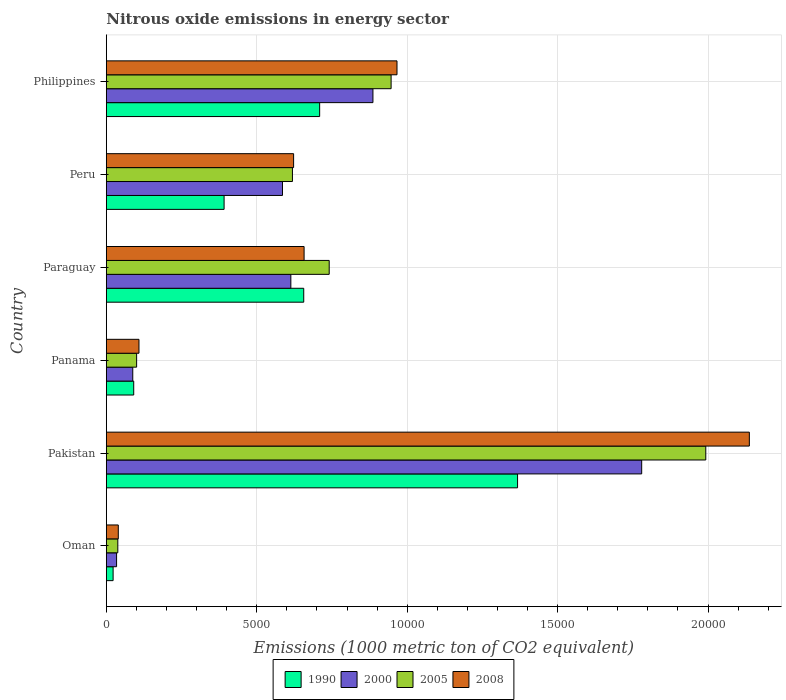How many groups of bars are there?
Offer a terse response. 6. What is the label of the 2nd group of bars from the top?
Ensure brevity in your answer.  Peru. What is the amount of nitrous oxide emitted in 1990 in Philippines?
Provide a succinct answer. 7090.2. Across all countries, what is the maximum amount of nitrous oxide emitted in 2005?
Provide a succinct answer. 1.99e+04. Across all countries, what is the minimum amount of nitrous oxide emitted in 2008?
Ensure brevity in your answer.  397.4. In which country was the amount of nitrous oxide emitted in 1990 minimum?
Your answer should be very brief. Oman. What is the total amount of nitrous oxide emitted in 2005 in the graph?
Ensure brevity in your answer.  4.44e+04. What is the difference between the amount of nitrous oxide emitted in 1990 in Oman and that in Panama?
Offer a terse response. -685.4. What is the difference between the amount of nitrous oxide emitted in 1990 in Panama and the amount of nitrous oxide emitted in 2008 in Pakistan?
Provide a short and direct response. -2.05e+04. What is the average amount of nitrous oxide emitted in 1990 per country?
Keep it short and to the point. 5394.85. What is the difference between the amount of nitrous oxide emitted in 2005 and amount of nitrous oxide emitted in 2008 in Paraguay?
Your answer should be compact. 834.7. What is the ratio of the amount of nitrous oxide emitted in 2005 in Pakistan to that in Paraguay?
Your response must be concise. 2.69. What is the difference between the highest and the second highest amount of nitrous oxide emitted in 2005?
Offer a terse response. 1.05e+04. What is the difference between the highest and the lowest amount of nitrous oxide emitted in 1990?
Give a very brief answer. 1.34e+04. In how many countries, is the amount of nitrous oxide emitted in 2008 greater than the average amount of nitrous oxide emitted in 2008 taken over all countries?
Offer a terse response. 2. Is it the case that in every country, the sum of the amount of nitrous oxide emitted in 2000 and amount of nitrous oxide emitted in 2005 is greater than the sum of amount of nitrous oxide emitted in 1990 and amount of nitrous oxide emitted in 2008?
Provide a short and direct response. No. What does the 4th bar from the top in Philippines represents?
Keep it short and to the point. 1990. Is it the case that in every country, the sum of the amount of nitrous oxide emitted in 2005 and amount of nitrous oxide emitted in 1990 is greater than the amount of nitrous oxide emitted in 2008?
Your answer should be compact. Yes. Are all the bars in the graph horizontal?
Offer a terse response. Yes. How many countries are there in the graph?
Your answer should be compact. 6. Are the values on the major ticks of X-axis written in scientific E-notation?
Your answer should be compact. No. Does the graph contain grids?
Your response must be concise. Yes. How many legend labels are there?
Ensure brevity in your answer.  4. What is the title of the graph?
Provide a succinct answer. Nitrous oxide emissions in energy sector. What is the label or title of the X-axis?
Your answer should be very brief. Emissions (1000 metric ton of CO2 equivalent). What is the Emissions (1000 metric ton of CO2 equivalent) of 1990 in Oman?
Ensure brevity in your answer.  225. What is the Emissions (1000 metric ton of CO2 equivalent) in 2000 in Oman?
Ensure brevity in your answer.  340.4. What is the Emissions (1000 metric ton of CO2 equivalent) in 2005 in Oman?
Provide a short and direct response. 381.4. What is the Emissions (1000 metric ton of CO2 equivalent) of 2008 in Oman?
Your answer should be compact. 397.4. What is the Emissions (1000 metric ton of CO2 equivalent) in 1990 in Pakistan?
Keep it short and to the point. 1.37e+04. What is the Emissions (1000 metric ton of CO2 equivalent) in 2000 in Pakistan?
Provide a short and direct response. 1.78e+04. What is the Emissions (1000 metric ton of CO2 equivalent) in 2005 in Pakistan?
Give a very brief answer. 1.99e+04. What is the Emissions (1000 metric ton of CO2 equivalent) in 2008 in Pakistan?
Offer a very short reply. 2.14e+04. What is the Emissions (1000 metric ton of CO2 equivalent) of 1990 in Panama?
Your answer should be compact. 910.4. What is the Emissions (1000 metric ton of CO2 equivalent) of 2000 in Panama?
Keep it short and to the point. 878.4. What is the Emissions (1000 metric ton of CO2 equivalent) in 2005 in Panama?
Provide a succinct answer. 1006.8. What is the Emissions (1000 metric ton of CO2 equivalent) of 2008 in Panama?
Offer a terse response. 1084.9. What is the Emissions (1000 metric ton of CO2 equivalent) in 1990 in Paraguay?
Keep it short and to the point. 6561.2. What is the Emissions (1000 metric ton of CO2 equivalent) in 2000 in Paraguay?
Make the answer very short. 6132.8. What is the Emissions (1000 metric ton of CO2 equivalent) of 2005 in Paraguay?
Your answer should be very brief. 7407.7. What is the Emissions (1000 metric ton of CO2 equivalent) in 2008 in Paraguay?
Ensure brevity in your answer.  6573. What is the Emissions (1000 metric ton of CO2 equivalent) in 1990 in Peru?
Provide a succinct answer. 3914.1. What is the Emissions (1000 metric ton of CO2 equivalent) in 2000 in Peru?
Offer a terse response. 5854.9. What is the Emissions (1000 metric ton of CO2 equivalent) of 2005 in Peru?
Your response must be concise. 6185.8. What is the Emissions (1000 metric ton of CO2 equivalent) in 2008 in Peru?
Provide a succinct answer. 6224.5. What is the Emissions (1000 metric ton of CO2 equivalent) of 1990 in Philippines?
Offer a very short reply. 7090.2. What is the Emissions (1000 metric ton of CO2 equivalent) of 2000 in Philippines?
Your response must be concise. 8861.1. What is the Emissions (1000 metric ton of CO2 equivalent) in 2005 in Philippines?
Provide a succinct answer. 9465.1. What is the Emissions (1000 metric ton of CO2 equivalent) of 2008 in Philippines?
Your answer should be compact. 9660.8. Across all countries, what is the maximum Emissions (1000 metric ton of CO2 equivalent) in 1990?
Provide a short and direct response. 1.37e+04. Across all countries, what is the maximum Emissions (1000 metric ton of CO2 equivalent) in 2000?
Make the answer very short. 1.78e+04. Across all countries, what is the maximum Emissions (1000 metric ton of CO2 equivalent) of 2005?
Your response must be concise. 1.99e+04. Across all countries, what is the maximum Emissions (1000 metric ton of CO2 equivalent) in 2008?
Make the answer very short. 2.14e+04. Across all countries, what is the minimum Emissions (1000 metric ton of CO2 equivalent) of 1990?
Ensure brevity in your answer.  225. Across all countries, what is the minimum Emissions (1000 metric ton of CO2 equivalent) of 2000?
Offer a terse response. 340.4. Across all countries, what is the minimum Emissions (1000 metric ton of CO2 equivalent) in 2005?
Offer a terse response. 381.4. Across all countries, what is the minimum Emissions (1000 metric ton of CO2 equivalent) of 2008?
Offer a very short reply. 397.4. What is the total Emissions (1000 metric ton of CO2 equivalent) in 1990 in the graph?
Provide a short and direct response. 3.24e+04. What is the total Emissions (1000 metric ton of CO2 equivalent) of 2000 in the graph?
Your response must be concise. 3.99e+04. What is the total Emissions (1000 metric ton of CO2 equivalent) in 2005 in the graph?
Provide a short and direct response. 4.44e+04. What is the total Emissions (1000 metric ton of CO2 equivalent) in 2008 in the graph?
Your answer should be compact. 4.53e+04. What is the difference between the Emissions (1000 metric ton of CO2 equivalent) of 1990 in Oman and that in Pakistan?
Your response must be concise. -1.34e+04. What is the difference between the Emissions (1000 metric ton of CO2 equivalent) of 2000 in Oman and that in Pakistan?
Keep it short and to the point. -1.75e+04. What is the difference between the Emissions (1000 metric ton of CO2 equivalent) of 2005 in Oman and that in Pakistan?
Give a very brief answer. -1.95e+04. What is the difference between the Emissions (1000 metric ton of CO2 equivalent) in 2008 in Oman and that in Pakistan?
Keep it short and to the point. -2.10e+04. What is the difference between the Emissions (1000 metric ton of CO2 equivalent) of 1990 in Oman and that in Panama?
Give a very brief answer. -685.4. What is the difference between the Emissions (1000 metric ton of CO2 equivalent) of 2000 in Oman and that in Panama?
Your answer should be very brief. -538. What is the difference between the Emissions (1000 metric ton of CO2 equivalent) of 2005 in Oman and that in Panama?
Your answer should be compact. -625.4. What is the difference between the Emissions (1000 metric ton of CO2 equivalent) of 2008 in Oman and that in Panama?
Keep it short and to the point. -687.5. What is the difference between the Emissions (1000 metric ton of CO2 equivalent) in 1990 in Oman and that in Paraguay?
Your answer should be very brief. -6336.2. What is the difference between the Emissions (1000 metric ton of CO2 equivalent) of 2000 in Oman and that in Paraguay?
Provide a short and direct response. -5792.4. What is the difference between the Emissions (1000 metric ton of CO2 equivalent) of 2005 in Oman and that in Paraguay?
Make the answer very short. -7026.3. What is the difference between the Emissions (1000 metric ton of CO2 equivalent) of 2008 in Oman and that in Paraguay?
Ensure brevity in your answer.  -6175.6. What is the difference between the Emissions (1000 metric ton of CO2 equivalent) of 1990 in Oman and that in Peru?
Your answer should be compact. -3689.1. What is the difference between the Emissions (1000 metric ton of CO2 equivalent) in 2000 in Oman and that in Peru?
Offer a very short reply. -5514.5. What is the difference between the Emissions (1000 metric ton of CO2 equivalent) of 2005 in Oman and that in Peru?
Your answer should be very brief. -5804.4. What is the difference between the Emissions (1000 metric ton of CO2 equivalent) in 2008 in Oman and that in Peru?
Provide a short and direct response. -5827.1. What is the difference between the Emissions (1000 metric ton of CO2 equivalent) of 1990 in Oman and that in Philippines?
Keep it short and to the point. -6865.2. What is the difference between the Emissions (1000 metric ton of CO2 equivalent) in 2000 in Oman and that in Philippines?
Offer a very short reply. -8520.7. What is the difference between the Emissions (1000 metric ton of CO2 equivalent) of 2005 in Oman and that in Philippines?
Make the answer very short. -9083.7. What is the difference between the Emissions (1000 metric ton of CO2 equivalent) in 2008 in Oman and that in Philippines?
Your answer should be very brief. -9263.4. What is the difference between the Emissions (1000 metric ton of CO2 equivalent) in 1990 in Pakistan and that in Panama?
Provide a short and direct response. 1.28e+04. What is the difference between the Emissions (1000 metric ton of CO2 equivalent) in 2000 in Pakistan and that in Panama?
Your answer should be very brief. 1.69e+04. What is the difference between the Emissions (1000 metric ton of CO2 equivalent) in 2005 in Pakistan and that in Panama?
Make the answer very short. 1.89e+04. What is the difference between the Emissions (1000 metric ton of CO2 equivalent) of 2008 in Pakistan and that in Panama?
Offer a very short reply. 2.03e+04. What is the difference between the Emissions (1000 metric ton of CO2 equivalent) of 1990 in Pakistan and that in Paraguay?
Provide a succinct answer. 7107. What is the difference between the Emissions (1000 metric ton of CO2 equivalent) of 2000 in Pakistan and that in Paraguay?
Make the answer very short. 1.17e+04. What is the difference between the Emissions (1000 metric ton of CO2 equivalent) of 2005 in Pakistan and that in Paraguay?
Provide a short and direct response. 1.25e+04. What is the difference between the Emissions (1000 metric ton of CO2 equivalent) of 2008 in Pakistan and that in Paraguay?
Make the answer very short. 1.48e+04. What is the difference between the Emissions (1000 metric ton of CO2 equivalent) in 1990 in Pakistan and that in Peru?
Offer a very short reply. 9754.1. What is the difference between the Emissions (1000 metric ton of CO2 equivalent) in 2000 in Pakistan and that in Peru?
Ensure brevity in your answer.  1.19e+04. What is the difference between the Emissions (1000 metric ton of CO2 equivalent) in 2005 in Pakistan and that in Peru?
Make the answer very short. 1.37e+04. What is the difference between the Emissions (1000 metric ton of CO2 equivalent) of 2008 in Pakistan and that in Peru?
Ensure brevity in your answer.  1.51e+04. What is the difference between the Emissions (1000 metric ton of CO2 equivalent) of 1990 in Pakistan and that in Philippines?
Offer a very short reply. 6578. What is the difference between the Emissions (1000 metric ton of CO2 equivalent) in 2000 in Pakistan and that in Philippines?
Provide a short and direct response. 8932.4. What is the difference between the Emissions (1000 metric ton of CO2 equivalent) in 2005 in Pakistan and that in Philippines?
Your response must be concise. 1.05e+04. What is the difference between the Emissions (1000 metric ton of CO2 equivalent) of 2008 in Pakistan and that in Philippines?
Ensure brevity in your answer.  1.17e+04. What is the difference between the Emissions (1000 metric ton of CO2 equivalent) of 1990 in Panama and that in Paraguay?
Offer a terse response. -5650.8. What is the difference between the Emissions (1000 metric ton of CO2 equivalent) of 2000 in Panama and that in Paraguay?
Ensure brevity in your answer.  -5254.4. What is the difference between the Emissions (1000 metric ton of CO2 equivalent) of 2005 in Panama and that in Paraguay?
Keep it short and to the point. -6400.9. What is the difference between the Emissions (1000 metric ton of CO2 equivalent) of 2008 in Panama and that in Paraguay?
Ensure brevity in your answer.  -5488.1. What is the difference between the Emissions (1000 metric ton of CO2 equivalent) of 1990 in Panama and that in Peru?
Provide a succinct answer. -3003.7. What is the difference between the Emissions (1000 metric ton of CO2 equivalent) of 2000 in Panama and that in Peru?
Ensure brevity in your answer.  -4976.5. What is the difference between the Emissions (1000 metric ton of CO2 equivalent) in 2005 in Panama and that in Peru?
Make the answer very short. -5179. What is the difference between the Emissions (1000 metric ton of CO2 equivalent) of 2008 in Panama and that in Peru?
Your answer should be compact. -5139.6. What is the difference between the Emissions (1000 metric ton of CO2 equivalent) in 1990 in Panama and that in Philippines?
Keep it short and to the point. -6179.8. What is the difference between the Emissions (1000 metric ton of CO2 equivalent) of 2000 in Panama and that in Philippines?
Provide a short and direct response. -7982.7. What is the difference between the Emissions (1000 metric ton of CO2 equivalent) in 2005 in Panama and that in Philippines?
Offer a very short reply. -8458.3. What is the difference between the Emissions (1000 metric ton of CO2 equivalent) in 2008 in Panama and that in Philippines?
Give a very brief answer. -8575.9. What is the difference between the Emissions (1000 metric ton of CO2 equivalent) of 1990 in Paraguay and that in Peru?
Your answer should be compact. 2647.1. What is the difference between the Emissions (1000 metric ton of CO2 equivalent) in 2000 in Paraguay and that in Peru?
Ensure brevity in your answer.  277.9. What is the difference between the Emissions (1000 metric ton of CO2 equivalent) in 2005 in Paraguay and that in Peru?
Your answer should be compact. 1221.9. What is the difference between the Emissions (1000 metric ton of CO2 equivalent) of 2008 in Paraguay and that in Peru?
Your response must be concise. 348.5. What is the difference between the Emissions (1000 metric ton of CO2 equivalent) of 1990 in Paraguay and that in Philippines?
Your answer should be compact. -529. What is the difference between the Emissions (1000 metric ton of CO2 equivalent) of 2000 in Paraguay and that in Philippines?
Ensure brevity in your answer.  -2728.3. What is the difference between the Emissions (1000 metric ton of CO2 equivalent) of 2005 in Paraguay and that in Philippines?
Your answer should be compact. -2057.4. What is the difference between the Emissions (1000 metric ton of CO2 equivalent) in 2008 in Paraguay and that in Philippines?
Provide a short and direct response. -3087.8. What is the difference between the Emissions (1000 metric ton of CO2 equivalent) of 1990 in Peru and that in Philippines?
Provide a short and direct response. -3176.1. What is the difference between the Emissions (1000 metric ton of CO2 equivalent) of 2000 in Peru and that in Philippines?
Ensure brevity in your answer.  -3006.2. What is the difference between the Emissions (1000 metric ton of CO2 equivalent) in 2005 in Peru and that in Philippines?
Provide a succinct answer. -3279.3. What is the difference between the Emissions (1000 metric ton of CO2 equivalent) of 2008 in Peru and that in Philippines?
Ensure brevity in your answer.  -3436.3. What is the difference between the Emissions (1000 metric ton of CO2 equivalent) of 1990 in Oman and the Emissions (1000 metric ton of CO2 equivalent) of 2000 in Pakistan?
Give a very brief answer. -1.76e+04. What is the difference between the Emissions (1000 metric ton of CO2 equivalent) in 1990 in Oman and the Emissions (1000 metric ton of CO2 equivalent) in 2005 in Pakistan?
Provide a succinct answer. -1.97e+04. What is the difference between the Emissions (1000 metric ton of CO2 equivalent) in 1990 in Oman and the Emissions (1000 metric ton of CO2 equivalent) in 2008 in Pakistan?
Give a very brief answer. -2.11e+04. What is the difference between the Emissions (1000 metric ton of CO2 equivalent) of 2000 in Oman and the Emissions (1000 metric ton of CO2 equivalent) of 2005 in Pakistan?
Your answer should be very brief. -1.96e+04. What is the difference between the Emissions (1000 metric ton of CO2 equivalent) in 2000 in Oman and the Emissions (1000 metric ton of CO2 equivalent) in 2008 in Pakistan?
Your answer should be compact. -2.10e+04. What is the difference between the Emissions (1000 metric ton of CO2 equivalent) of 2005 in Oman and the Emissions (1000 metric ton of CO2 equivalent) of 2008 in Pakistan?
Offer a very short reply. -2.10e+04. What is the difference between the Emissions (1000 metric ton of CO2 equivalent) in 1990 in Oman and the Emissions (1000 metric ton of CO2 equivalent) in 2000 in Panama?
Give a very brief answer. -653.4. What is the difference between the Emissions (1000 metric ton of CO2 equivalent) of 1990 in Oman and the Emissions (1000 metric ton of CO2 equivalent) of 2005 in Panama?
Your answer should be very brief. -781.8. What is the difference between the Emissions (1000 metric ton of CO2 equivalent) in 1990 in Oman and the Emissions (1000 metric ton of CO2 equivalent) in 2008 in Panama?
Your response must be concise. -859.9. What is the difference between the Emissions (1000 metric ton of CO2 equivalent) of 2000 in Oman and the Emissions (1000 metric ton of CO2 equivalent) of 2005 in Panama?
Ensure brevity in your answer.  -666.4. What is the difference between the Emissions (1000 metric ton of CO2 equivalent) of 2000 in Oman and the Emissions (1000 metric ton of CO2 equivalent) of 2008 in Panama?
Ensure brevity in your answer.  -744.5. What is the difference between the Emissions (1000 metric ton of CO2 equivalent) in 2005 in Oman and the Emissions (1000 metric ton of CO2 equivalent) in 2008 in Panama?
Your answer should be compact. -703.5. What is the difference between the Emissions (1000 metric ton of CO2 equivalent) of 1990 in Oman and the Emissions (1000 metric ton of CO2 equivalent) of 2000 in Paraguay?
Keep it short and to the point. -5907.8. What is the difference between the Emissions (1000 metric ton of CO2 equivalent) of 1990 in Oman and the Emissions (1000 metric ton of CO2 equivalent) of 2005 in Paraguay?
Offer a very short reply. -7182.7. What is the difference between the Emissions (1000 metric ton of CO2 equivalent) of 1990 in Oman and the Emissions (1000 metric ton of CO2 equivalent) of 2008 in Paraguay?
Your answer should be compact. -6348. What is the difference between the Emissions (1000 metric ton of CO2 equivalent) of 2000 in Oman and the Emissions (1000 metric ton of CO2 equivalent) of 2005 in Paraguay?
Your answer should be very brief. -7067.3. What is the difference between the Emissions (1000 metric ton of CO2 equivalent) of 2000 in Oman and the Emissions (1000 metric ton of CO2 equivalent) of 2008 in Paraguay?
Give a very brief answer. -6232.6. What is the difference between the Emissions (1000 metric ton of CO2 equivalent) in 2005 in Oman and the Emissions (1000 metric ton of CO2 equivalent) in 2008 in Paraguay?
Ensure brevity in your answer.  -6191.6. What is the difference between the Emissions (1000 metric ton of CO2 equivalent) of 1990 in Oman and the Emissions (1000 metric ton of CO2 equivalent) of 2000 in Peru?
Your response must be concise. -5629.9. What is the difference between the Emissions (1000 metric ton of CO2 equivalent) in 1990 in Oman and the Emissions (1000 metric ton of CO2 equivalent) in 2005 in Peru?
Offer a very short reply. -5960.8. What is the difference between the Emissions (1000 metric ton of CO2 equivalent) in 1990 in Oman and the Emissions (1000 metric ton of CO2 equivalent) in 2008 in Peru?
Ensure brevity in your answer.  -5999.5. What is the difference between the Emissions (1000 metric ton of CO2 equivalent) of 2000 in Oman and the Emissions (1000 metric ton of CO2 equivalent) of 2005 in Peru?
Offer a very short reply. -5845.4. What is the difference between the Emissions (1000 metric ton of CO2 equivalent) in 2000 in Oman and the Emissions (1000 metric ton of CO2 equivalent) in 2008 in Peru?
Offer a very short reply. -5884.1. What is the difference between the Emissions (1000 metric ton of CO2 equivalent) in 2005 in Oman and the Emissions (1000 metric ton of CO2 equivalent) in 2008 in Peru?
Make the answer very short. -5843.1. What is the difference between the Emissions (1000 metric ton of CO2 equivalent) in 1990 in Oman and the Emissions (1000 metric ton of CO2 equivalent) in 2000 in Philippines?
Offer a terse response. -8636.1. What is the difference between the Emissions (1000 metric ton of CO2 equivalent) in 1990 in Oman and the Emissions (1000 metric ton of CO2 equivalent) in 2005 in Philippines?
Your answer should be very brief. -9240.1. What is the difference between the Emissions (1000 metric ton of CO2 equivalent) of 1990 in Oman and the Emissions (1000 metric ton of CO2 equivalent) of 2008 in Philippines?
Provide a short and direct response. -9435.8. What is the difference between the Emissions (1000 metric ton of CO2 equivalent) in 2000 in Oman and the Emissions (1000 metric ton of CO2 equivalent) in 2005 in Philippines?
Give a very brief answer. -9124.7. What is the difference between the Emissions (1000 metric ton of CO2 equivalent) in 2000 in Oman and the Emissions (1000 metric ton of CO2 equivalent) in 2008 in Philippines?
Provide a short and direct response. -9320.4. What is the difference between the Emissions (1000 metric ton of CO2 equivalent) of 2005 in Oman and the Emissions (1000 metric ton of CO2 equivalent) of 2008 in Philippines?
Ensure brevity in your answer.  -9279.4. What is the difference between the Emissions (1000 metric ton of CO2 equivalent) of 1990 in Pakistan and the Emissions (1000 metric ton of CO2 equivalent) of 2000 in Panama?
Keep it short and to the point. 1.28e+04. What is the difference between the Emissions (1000 metric ton of CO2 equivalent) in 1990 in Pakistan and the Emissions (1000 metric ton of CO2 equivalent) in 2005 in Panama?
Offer a terse response. 1.27e+04. What is the difference between the Emissions (1000 metric ton of CO2 equivalent) in 1990 in Pakistan and the Emissions (1000 metric ton of CO2 equivalent) in 2008 in Panama?
Make the answer very short. 1.26e+04. What is the difference between the Emissions (1000 metric ton of CO2 equivalent) in 2000 in Pakistan and the Emissions (1000 metric ton of CO2 equivalent) in 2005 in Panama?
Ensure brevity in your answer.  1.68e+04. What is the difference between the Emissions (1000 metric ton of CO2 equivalent) of 2000 in Pakistan and the Emissions (1000 metric ton of CO2 equivalent) of 2008 in Panama?
Offer a terse response. 1.67e+04. What is the difference between the Emissions (1000 metric ton of CO2 equivalent) in 2005 in Pakistan and the Emissions (1000 metric ton of CO2 equivalent) in 2008 in Panama?
Your answer should be very brief. 1.88e+04. What is the difference between the Emissions (1000 metric ton of CO2 equivalent) in 1990 in Pakistan and the Emissions (1000 metric ton of CO2 equivalent) in 2000 in Paraguay?
Your answer should be very brief. 7535.4. What is the difference between the Emissions (1000 metric ton of CO2 equivalent) of 1990 in Pakistan and the Emissions (1000 metric ton of CO2 equivalent) of 2005 in Paraguay?
Ensure brevity in your answer.  6260.5. What is the difference between the Emissions (1000 metric ton of CO2 equivalent) of 1990 in Pakistan and the Emissions (1000 metric ton of CO2 equivalent) of 2008 in Paraguay?
Provide a succinct answer. 7095.2. What is the difference between the Emissions (1000 metric ton of CO2 equivalent) in 2000 in Pakistan and the Emissions (1000 metric ton of CO2 equivalent) in 2005 in Paraguay?
Offer a terse response. 1.04e+04. What is the difference between the Emissions (1000 metric ton of CO2 equivalent) of 2000 in Pakistan and the Emissions (1000 metric ton of CO2 equivalent) of 2008 in Paraguay?
Ensure brevity in your answer.  1.12e+04. What is the difference between the Emissions (1000 metric ton of CO2 equivalent) of 2005 in Pakistan and the Emissions (1000 metric ton of CO2 equivalent) of 2008 in Paraguay?
Your answer should be compact. 1.34e+04. What is the difference between the Emissions (1000 metric ton of CO2 equivalent) of 1990 in Pakistan and the Emissions (1000 metric ton of CO2 equivalent) of 2000 in Peru?
Ensure brevity in your answer.  7813.3. What is the difference between the Emissions (1000 metric ton of CO2 equivalent) in 1990 in Pakistan and the Emissions (1000 metric ton of CO2 equivalent) in 2005 in Peru?
Make the answer very short. 7482.4. What is the difference between the Emissions (1000 metric ton of CO2 equivalent) in 1990 in Pakistan and the Emissions (1000 metric ton of CO2 equivalent) in 2008 in Peru?
Your response must be concise. 7443.7. What is the difference between the Emissions (1000 metric ton of CO2 equivalent) of 2000 in Pakistan and the Emissions (1000 metric ton of CO2 equivalent) of 2005 in Peru?
Give a very brief answer. 1.16e+04. What is the difference between the Emissions (1000 metric ton of CO2 equivalent) in 2000 in Pakistan and the Emissions (1000 metric ton of CO2 equivalent) in 2008 in Peru?
Your answer should be compact. 1.16e+04. What is the difference between the Emissions (1000 metric ton of CO2 equivalent) in 2005 in Pakistan and the Emissions (1000 metric ton of CO2 equivalent) in 2008 in Peru?
Give a very brief answer. 1.37e+04. What is the difference between the Emissions (1000 metric ton of CO2 equivalent) of 1990 in Pakistan and the Emissions (1000 metric ton of CO2 equivalent) of 2000 in Philippines?
Provide a short and direct response. 4807.1. What is the difference between the Emissions (1000 metric ton of CO2 equivalent) in 1990 in Pakistan and the Emissions (1000 metric ton of CO2 equivalent) in 2005 in Philippines?
Your answer should be compact. 4203.1. What is the difference between the Emissions (1000 metric ton of CO2 equivalent) in 1990 in Pakistan and the Emissions (1000 metric ton of CO2 equivalent) in 2008 in Philippines?
Your answer should be very brief. 4007.4. What is the difference between the Emissions (1000 metric ton of CO2 equivalent) of 2000 in Pakistan and the Emissions (1000 metric ton of CO2 equivalent) of 2005 in Philippines?
Keep it short and to the point. 8328.4. What is the difference between the Emissions (1000 metric ton of CO2 equivalent) of 2000 in Pakistan and the Emissions (1000 metric ton of CO2 equivalent) of 2008 in Philippines?
Your answer should be compact. 8132.7. What is the difference between the Emissions (1000 metric ton of CO2 equivalent) in 2005 in Pakistan and the Emissions (1000 metric ton of CO2 equivalent) in 2008 in Philippines?
Keep it short and to the point. 1.03e+04. What is the difference between the Emissions (1000 metric ton of CO2 equivalent) in 1990 in Panama and the Emissions (1000 metric ton of CO2 equivalent) in 2000 in Paraguay?
Make the answer very short. -5222.4. What is the difference between the Emissions (1000 metric ton of CO2 equivalent) in 1990 in Panama and the Emissions (1000 metric ton of CO2 equivalent) in 2005 in Paraguay?
Ensure brevity in your answer.  -6497.3. What is the difference between the Emissions (1000 metric ton of CO2 equivalent) of 1990 in Panama and the Emissions (1000 metric ton of CO2 equivalent) of 2008 in Paraguay?
Offer a very short reply. -5662.6. What is the difference between the Emissions (1000 metric ton of CO2 equivalent) of 2000 in Panama and the Emissions (1000 metric ton of CO2 equivalent) of 2005 in Paraguay?
Your response must be concise. -6529.3. What is the difference between the Emissions (1000 metric ton of CO2 equivalent) in 2000 in Panama and the Emissions (1000 metric ton of CO2 equivalent) in 2008 in Paraguay?
Your answer should be compact. -5694.6. What is the difference between the Emissions (1000 metric ton of CO2 equivalent) in 2005 in Panama and the Emissions (1000 metric ton of CO2 equivalent) in 2008 in Paraguay?
Your response must be concise. -5566.2. What is the difference between the Emissions (1000 metric ton of CO2 equivalent) of 1990 in Panama and the Emissions (1000 metric ton of CO2 equivalent) of 2000 in Peru?
Provide a succinct answer. -4944.5. What is the difference between the Emissions (1000 metric ton of CO2 equivalent) of 1990 in Panama and the Emissions (1000 metric ton of CO2 equivalent) of 2005 in Peru?
Make the answer very short. -5275.4. What is the difference between the Emissions (1000 metric ton of CO2 equivalent) of 1990 in Panama and the Emissions (1000 metric ton of CO2 equivalent) of 2008 in Peru?
Offer a very short reply. -5314.1. What is the difference between the Emissions (1000 metric ton of CO2 equivalent) of 2000 in Panama and the Emissions (1000 metric ton of CO2 equivalent) of 2005 in Peru?
Your answer should be very brief. -5307.4. What is the difference between the Emissions (1000 metric ton of CO2 equivalent) of 2000 in Panama and the Emissions (1000 metric ton of CO2 equivalent) of 2008 in Peru?
Your answer should be compact. -5346.1. What is the difference between the Emissions (1000 metric ton of CO2 equivalent) in 2005 in Panama and the Emissions (1000 metric ton of CO2 equivalent) in 2008 in Peru?
Your answer should be very brief. -5217.7. What is the difference between the Emissions (1000 metric ton of CO2 equivalent) in 1990 in Panama and the Emissions (1000 metric ton of CO2 equivalent) in 2000 in Philippines?
Make the answer very short. -7950.7. What is the difference between the Emissions (1000 metric ton of CO2 equivalent) in 1990 in Panama and the Emissions (1000 metric ton of CO2 equivalent) in 2005 in Philippines?
Provide a succinct answer. -8554.7. What is the difference between the Emissions (1000 metric ton of CO2 equivalent) in 1990 in Panama and the Emissions (1000 metric ton of CO2 equivalent) in 2008 in Philippines?
Make the answer very short. -8750.4. What is the difference between the Emissions (1000 metric ton of CO2 equivalent) of 2000 in Panama and the Emissions (1000 metric ton of CO2 equivalent) of 2005 in Philippines?
Ensure brevity in your answer.  -8586.7. What is the difference between the Emissions (1000 metric ton of CO2 equivalent) in 2000 in Panama and the Emissions (1000 metric ton of CO2 equivalent) in 2008 in Philippines?
Your response must be concise. -8782.4. What is the difference between the Emissions (1000 metric ton of CO2 equivalent) of 2005 in Panama and the Emissions (1000 metric ton of CO2 equivalent) of 2008 in Philippines?
Provide a short and direct response. -8654. What is the difference between the Emissions (1000 metric ton of CO2 equivalent) in 1990 in Paraguay and the Emissions (1000 metric ton of CO2 equivalent) in 2000 in Peru?
Provide a short and direct response. 706.3. What is the difference between the Emissions (1000 metric ton of CO2 equivalent) of 1990 in Paraguay and the Emissions (1000 metric ton of CO2 equivalent) of 2005 in Peru?
Keep it short and to the point. 375.4. What is the difference between the Emissions (1000 metric ton of CO2 equivalent) of 1990 in Paraguay and the Emissions (1000 metric ton of CO2 equivalent) of 2008 in Peru?
Your answer should be compact. 336.7. What is the difference between the Emissions (1000 metric ton of CO2 equivalent) of 2000 in Paraguay and the Emissions (1000 metric ton of CO2 equivalent) of 2005 in Peru?
Offer a terse response. -53. What is the difference between the Emissions (1000 metric ton of CO2 equivalent) of 2000 in Paraguay and the Emissions (1000 metric ton of CO2 equivalent) of 2008 in Peru?
Offer a terse response. -91.7. What is the difference between the Emissions (1000 metric ton of CO2 equivalent) in 2005 in Paraguay and the Emissions (1000 metric ton of CO2 equivalent) in 2008 in Peru?
Offer a terse response. 1183.2. What is the difference between the Emissions (1000 metric ton of CO2 equivalent) in 1990 in Paraguay and the Emissions (1000 metric ton of CO2 equivalent) in 2000 in Philippines?
Provide a short and direct response. -2299.9. What is the difference between the Emissions (1000 metric ton of CO2 equivalent) of 1990 in Paraguay and the Emissions (1000 metric ton of CO2 equivalent) of 2005 in Philippines?
Offer a terse response. -2903.9. What is the difference between the Emissions (1000 metric ton of CO2 equivalent) in 1990 in Paraguay and the Emissions (1000 metric ton of CO2 equivalent) in 2008 in Philippines?
Give a very brief answer. -3099.6. What is the difference between the Emissions (1000 metric ton of CO2 equivalent) of 2000 in Paraguay and the Emissions (1000 metric ton of CO2 equivalent) of 2005 in Philippines?
Offer a terse response. -3332.3. What is the difference between the Emissions (1000 metric ton of CO2 equivalent) of 2000 in Paraguay and the Emissions (1000 metric ton of CO2 equivalent) of 2008 in Philippines?
Your response must be concise. -3528. What is the difference between the Emissions (1000 metric ton of CO2 equivalent) of 2005 in Paraguay and the Emissions (1000 metric ton of CO2 equivalent) of 2008 in Philippines?
Make the answer very short. -2253.1. What is the difference between the Emissions (1000 metric ton of CO2 equivalent) of 1990 in Peru and the Emissions (1000 metric ton of CO2 equivalent) of 2000 in Philippines?
Provide a succinct answer. -4947. What is the difference between the Emissions (1000 metric ton of CO2 equivalent) in 1990 in Peru and the Emissions (1000 metric ton of CO2 equivalent) in 2005 in Philippines?
Keep it short and to the point. -5551. What is the difference between the Emissions (1000 metric ton of CO2 equivalent) in 1990 in Peru and the Emissions (1000 metric ton of CO2 equivalent) in 2008 in Philippines?
Offer a terse response. -5746.7. What is the difference between the Emissions (1000 metric ton of CO2 equivalent) in 2000 in Peru and the Emissions (1000 metric ton of CO2 equivalent) in 2005 in Philippines?
Keep it short and to the point. -3610.2. What is the difference between the Emissions (1000 metric ton of CO2 equivalent) in 2000 in Peru and the Emissions (1000 metric ton of CO2 equivalent) in 2008 in Philippines?
Offer a terse response. -3805.9. What is the difference between the Emissions (1000 metric ton of CO2 equivalent) of 2005 in Peru and the Emissions (1000 metric ton of CO2 equivalent) of 2008 in Philippines?
Offer a terse response. -3475. What is the average Emissions (1000 metric ton of CO2 equivalent) in 1990 per country?
Provide a succinct answer. 5394.85. What is the average Emissions (1000 metric ton of CO2 equivalent) of 2000 per country?
Keep it short and to the point. 6643.52. What is the average Emissions (1000 metric ton of CO2 equivalent) in 2005 per country?
Make the answer very short. 7395.13. What is the average Emissions (1000 metric ton of CO2 equivalent) of 2008 per country?
Keep it short and to the point. 7552.07. What is the difference between the Emissions (1000 metric ton of CO2 equivalent) of 1990 and Emissions (1000 metric ton of CO2 equivalent) of 2000 in Oman?
Make the answer very short. -115.4. What is the difference between the Emissions (1000 metric ton of CO2 equivalent) of 1990 and Emissions (1000 metric ton of CO2 equivalent) of 2005 in Oman?
Make the answer very short. -156.4. What is the difference between the Emissions (1000 metric ton of CO2 equivalent) of 1990 and Emissions (1000 metric ton of CO2 equivalent) of 2008 in Oman?
Provide a short and direct response. -172.4. What is the difference between the Emissions (1000 metric ton of CO2 equivalent) of 2000 and Emissions (1000 metric ton of CO2 equivalent) of 2005 in Oman?
Offer a terse response. -41. What is the difference between the Emissions (1000 metric ton of CO2 equivalent) in 2000 and Emissions (1000 metric ton of CO2 equivalent) in 2008 in Oman?
Make the answer very short. -57. What is the difference between the Emissions (1000 metric ton of CO2 equivalent) in 1990 and Emissions (1000 metric ton of CO2 equivalent) in 2000 in Pakistan?
Provide a short and direct response. -4125.3. What is the difference between the Emissions (1000 metric ton of CO2 equivalent) in 1990 and Emissions (1000 metric ton of CO2 equivalent) in 2005 in Pakistan?
Your answer should be compact. -6255.8. What is the difference between the Emissions (1000 metric ton of CO2 equivalent) in 1990 and Emissions (1000 metric ton of CO2 equivalent) in 2008 in Pakistan?
Offer a terse response. -7703.6. What is the difference between the Emissions (1000 metric ton of CO2 equivalent) of 2000 and Emissions (1000 metric ton of CO2 equivalent) of 2005 in Pakistan?
Your answer should be very brief. -2130.5. What is the difference between the Emissions (1000 metric ton of CO2 equivalent) in 2000 and Emissions (1000 metric ton of CO2 equivalent) in 2008 in Pakistan?
Offer a very short reply. -3578.3. What is the difference between the Emissions (1000 metric ton of CO2 equivalent) of 2005 and Emissions (1000 metric ton of CO2 equivalent) of 2008 in Pakistan?
Your response must be concise. -1447.8. What is the difference between the Emissions (1000 metric ton of CO2 equivalent) in 1990 and Emissions (1000 metric ton of CO2 equivalent) in 2000 in Panama?
Your response must be concise. 32. What is the difference between the Emissions (1000 metric ton of CO2 equivalent) in 1990 and Emissions (1000 metric ton of CO2 equivalent) in 2005 in Panama?
Your answer should be compact. -96.4. What is the difference between the Emissions (1000 metric ton of CO2 equivalent) of 1990 and Emissions (1000 metric ton of CO2 equivalent) of 2008 in Panama?
Keep it short and to the point. -174.5. What is the difference between the Emissions (1000 metric ton of CO2 equivalent) of 2000 and Emissions (1000 metric ton of CO2 equivalent) of 2005 in Panama?
Offer a terse response. -128.4. What is the difference between the Emissions (1000 metric ton of CO2 equivalent) in 2000 and Emissions (1000 metric ton of CO2 equivalent) in 2008 in Panama?
Make the answer very short. -206.5. What is the difference between the Emissions (1000 metric ton of CO2 equivalent) in 2005 and Emissions (1000 metric ton of CO2 equivalent) in 2008 in Panama?
Keep it short and to the point. -78.1. What is the difference between the Emissions (1000 metric ton of CO2 equivalent) in 1990 and Emissions (1000 metric ton of CO2 equivalent) in 2000 in Paraguay?
Your answer should be very brief. 428.4. What is the difference between the Emissions (1000 metric ton of CO2 equivalent) of 1990 and Emissions (1000 metric ton of CO2 equivalent) of 2005 in Paraguay?
Offer a very short reply. -846.5. What is the difference between the Emissions (1000 metric ton of CO2 equivalent) in 1990 and Emissions (1000 metric ton of CO2 equivalent) in 2008 in Paraguay?
Provide a short and direct response. -11.8. What is the difference between the Emissions (1000 metric ton of CO2 equivalent) in 2000 and Emissions (1000 metric ton of CO2 equivalent) in 2005 in Paraguay?
Your response must be concise. -1274.9. What is the difference between the Emissions (1000 metric ton of CO2 equivalent) in 2000 and Emissions (1000 metric ton of CO2 equivalent) in 2008 in Paraguay?
Your answer should be very brief. -440.2. What is the difference between the Emissions (1000 metric ton of CO2 equivalent) in 2005 and Emissions (1000 metric ton of CO2 equivalent) in 2008 in Paraguay?
Make the answer very short. 834.7. What is the difference between the Emissions (1000 metric ton of CO2 equivalent) in 1990 and Emissions (1000 metric ton of CO2 equivalent) in 2000 in Peru?
Ensure brevity in your answer.  -1940.8. What is the difference between the Emissions (1000 metric ton of CO2 equivalent) of 1990 and Emissions (1000 metric ton of CO2 equivalent) of 2005 in Peru?
Your answer should be compact. -2271.7. What is the difference between the Emissions (1000 metric ton of CO2 equivalent) of 1990 and Emissions (1000 metric ton of CO2 equivalent) of 2008 in Peru?
Your response must be concise. -2310.4. What is the difference between the Emissions (1000 metric ton of CO2 equivalent) in 2000 and Emissions (1000 metric ton of CO2 equivalent) in 2005 in Peru?
Your answer should be very brief. -330.9. What is the difference between the Emissions (1000 metric ton of CO2 equivalent) of 2000 and Emissions (1000 metric ton of CO2 equivalent) of 2008 in Peru?
Keep it short and to the point. -369.6. What is the difference between the Emissions (1000 metric ton of CO2 equivalent) in 2005 and Emissions (1000 metric ton of CO2 equivalent) in 2008 in Peru?
Give a very brief answer. -38.7. What is the difference between the Emissions (1000 metric ton of CO2 equivalent) of 1990 and Emissions (1000 metric ton of CO2 equivalent) of 2000 in Philippines?
Offer a very short reply. -1770.9. What is the difference between the Emissions (1000 metric ton of CO2 equivalent) in 1990 and Emissions (1000 metric ton of CO2 equivalent) in 2005 in Philippines?
Offer a very short reply. -2374.9. What is the difference between the Emissions (1000 metric ton of CO2 equivalent) of 1990 and Emissions (1000 metric ton of CO2 equivalent) of 2008 in Philippines?
Provide a succinct answer. -2570.6. What is the difference between the Emissions (1000 metric ton of CO2 equivalent) in 2000 and Emissions (1000 metric ton of CO2 equivalent) in 2005 in Philippines?
Provide a short and direct response. -604. What is the difference between the Emissions (1000 metric ton of CO2 equivalent) in 2000 and Emissions (1000 metric ton of CO2 equivalent) in 2008 in Philippines?
Your answer should be compact. -799.7. What is the difference between the Emissions (1000 metric ton of CO2 equivalent) of 2005 and Emissions (1000 metric ton of CO2 equivalent) of 2008 in Philippines?
Offer a terse response. -195.7. What is the ratio of the Emissions (1000 metric ton of CO2 equivalent) of 1990 in Oman to that in Pakistan?
Keep it short and to the point. 0.02. What is the ratio of the Emissions (1000 metric ton of CO2 equivalent) of 2000 in Oman to that in Pakistan?
Your response must be concise. 0.02. What is the ratio of the Emissions (1000 metric ton of CO2 equivalent) of 2005 in Oman to that in Pakistan?
Your response must be concise. 0.02. What is the ratio of the Emissions (1000 metric ton of CO2 equivalent) in 2008 in Oman to that in Pakistan?
Provide a short and direct response. 0.02. What is the ratio of the Emissions (1000 metric ton of CO2 equivalent) of 1990 in Oman to that in Panama?
Your answer should be very brief. 0.25. What is the ratio of the Emissions (1000 metric ton of CO2 equivalent) in 2000 in Oman to that in Panama?
Ensure brevity in your answer.  0.39. What is the ratio of the Emissions (1000 metric ton of CO2 equivalent) in 2005 in Oman to that in Panama?
Keep it short and to the point. 0.38. What is the ratio of the Emissions (1000 metric ton of CO2 equivalent) in 2008 in Oman to that in Panama?
Give a very brief answer. 0.37. What is the ratio of the Emissions (1000 metric ton of CO2 equivalent) in 1990 in Oman to that in Paraguay?
Your answer should be compact. 0.03. What is the ratio of the Emissions (1000 metric ton of CO2 equivalent) in 2000 in Oman to that in Paraguay?
Your answer should be compact. 0.06. What is the ratio of the Emissions (1000 metric ton of CO2 equivalent) of 2005 in Oman to that in Paraguay?
Give a very brief answer. 0.05. What is the ratio of the Emissions (1000 metric ton of CO2 equivalent) of 2008 in Oman to that in Paraguay?
Offer a terse response. 0.06. What is the ratio of the Emissions (1000 metric ton of CO2 equivalent) of 1990 in Oman to that in Peru?
Your answer should be compact. 0.06. What is the ratio of the Emissions (1000 metric ton of CO2 equivalent) of 2000 in Oman to that in Peru?
Make the answer very short. 0.06. What is the ratio of the Emissions (1000 metric ton of CO2 equivalent) in 2005 in Oman to that in Peru?
Make the answer very short. 0.06. What is the ratio of the Emissions (1000 metric ton of CO2 equivalent) of 2008 in Oman to that in Peru?
Provide a short and direct response. 0.06. What is the ratio of the Emissions (1000 metric ton of CO2 equivalent) in 1990 in Oman to that in Philippines?
Your response must be concise. 0.03. What is the ratio of the Emissions (1000 metric ton of CO2 equivalent) of 2000 in Oman to that in Philippines?
Give a very brief answer. 0.04. What is the ratio of the Emissions (1000 metric ton of CO2 equivalent) of 2005 in Oman to that in Philippines?
Your response must be concise. 0.04. What is the ratio of the Emissions (1000 metric ton of CO2 equivalent) in 2008 in Oman to that in Philippines?
Give a very brief answer. 0.04. What is the ratio of the Emissions (1000 metric ton of CO2 equivalent) of 1990 in Pakistan to that in Panama?
Provide a succinct answer. 15.01. What is the ratio of the Emissions (1000 metric ton of CO2 equivalent) in 2000 in Pakistan to that in Panama?
Keep it short and to the point. 20.26. What is the ratio of the Emissions (1000 metric ton of CO2 equivalent) in 2005 in Pakistan to that in Panama?
Provide a succinct answer. 19.79. What is the ratio of the Emissions (1000 metric ton of CO2 equivalent) of 2008 in Pakistan to that in Panama?
Your response must be concise. 19.7. What is the ratio of the Emissions (1000 metric ton of CO2 equivalent) of 1990 in Pakistan to that in Paraguay?
Ensure brevity in your answer.  2.08. What is the ratio of the Emissions (1000 metric ton of CO2 equivalent) of 2000 in Pakistan to that in Paraguay?
Keep it short and to the point. 2.9. What is the ratio of the Emissions (1000 metric ton of CO2 equivalent) in 2005 in Pakistan to that in Paraguay?
Your response must be concise. 2.69. What is the ratio of the Emissions (1000 metric ton of CO2 equivalent) of 2008 in Pakistan to that in Paraguay?
Provide a short and direct response. 3.25. What is the ratio of the Emissions (1000 metric ton of CO2 equivalent) of 1990 in Pakistan to that in Peru?
Give a very brief answer. 3.49. What is the ratio of the Emissions (1000 metric ton of CO2 equivalent) of 2000 in Pakistan to that in Peru?
Provide a short and direct response. 3.04. What is the ratio of the Emissions (1000 metric ton of CO2 equivalent) of 2005 in Pakistan to that in Peru?
Your answer should be compact. 3.22. What is the ratio of the Emissions (1000 metric ton of CO2 equivalent) of 2008 in Pakistan to that in Peru?
Keep it short and to the point. 3.43. What is the ratio of the Emissions (1000 metric ton of CO2 equivalent) in 1990 in Pakistan to that in Philippines?
Offer a terse response. 1.93. What is the ratio of the Emissions (1000 metric ton of CO2 equivalent) of 2000 in Pakistan to that in Philippines?
Make the answer very short. 2.01. What is the ratio of the Emissions (1000 metric ton of CO2 equivalent) of 2005 in Pakistan to that in Philippines?
Keep it short and to the point. 2.1. What is the ratio of the Emissions (1000 metric ton of CO2 equivalent) of 2008 in Pakistan to that in Philippines?
Your answer should be very brief. 2.21. What is the ratio of the Emissions (1000 metric ton of CO2 equivalent) of 1990 in Panama to that in Paraguay?
Give a very brief answer. 0.14. What is the ratio of the Emissions (1000 metric ton of CO2 equivalent) in 2000 in Panama to that in Paraguay?
Make the answer very short. 0.14. What is the ratio of the Emissions (1000 metric ton of CO2 equivalent) of 2005 in Panama to that in Paraguay?
Offer a very short reply. 0.14. What is the ratio of the Emissions (1000 metric ton of CO2 equivalent) of 2008 in Panama to that in Paraguay?
Offer a very short reply. 0.17. What is the ratio of the Emissions (1000 metric ton of CO2 equivalent) of 1990 in Panama to that in Peru?
Your answer should be very brief. 0.23. What is the ratio of the Emissions (1000 metric ton of CO2 equivalent) of 2000 in Panama to that in Peru?
Offer a terse response. 0.15. What is the ratio of the Emissions (1000 metric ton of CO2 equivalent) of 2005 in Panama to that in Peru?
Your answer should be very brief. 0.16. What is the ratio of the Emissions (1000 metric ton of CO2 equivalent) in 2008 in Panama to that in Peru?
Provide a short and direct response. 0.17. What is the ratio of the Emissions (1000 metric ton of CO2 equivalent) of 1990 in Panama to that in Philippines?
Provide a short and direct response. 0.13. What is the ratio of the Emissions (1000 metric ton of CO2 equivalent) of 2000 in Panama to that in Philippines?
Your response must be concise. 0.1. What is the ratio of the Emissions (1000 metric ton of CO2 equivalent) of 2005 in Panama to that in Philippines?
Give a very brief answer. 0.11. What is the ratio of the Emissions (1000 metric ton of CO2 equivalent) in 2008 in Panama to that in Philippines?
Offer a terse response. 0.11. What is the ratio of the Emissions (1000 metric ton of CO2 equivalent) in 1990 in Paraguay to that in Peru?
Your answer should be compact. 1.68. What is the ratio of the Emissions (1000 metric ton of CO2 equivalent) in 2000 in Paraguay to that in Peru?
Make the answer very short. 1.05. What is the ratio of the Emissions (1000 metric ton of CO2 equivalent) in 2005 in Paraguay to that in Peru?
Ensure brevity in your answer.  1.2. What is the ratio of the Emissions (1000 metric ton of CO2 equivalent) of 2008 in Paraguay to that in Peru?
Give a very brief answer. 1.06. What is the ratio of the Emissions (1000 metric ton of CO2 equivalent) in 1990 in Paraguay to that in Philippines?
Your answer should be very brief. 0.93. What is the ratio of the Emissions (1000 metric ton of CO2 equivalent) in 2000 in Paraguay to that in Philippines?
Keep it short and to the point. 0.69. What is the ratio of the Emissions (1000 metric ton of CO2 equivalent) in 2005 in Paraguay to that in Philippines?
Offer a terse response. 0.78. What is the ratio of the Emissions (1000 metric ton of CO2 equivalent) in 2008 in Paraguay to that in Philippines?
Your answer should be compact. 0.68. What is the ratio of the Emissions (1000 metric ton of CO2 equivalent) of 1990 in Peru to that in Philippines?
Ensure brevity in your answer.  0.55. What is the ratio of the Emissions (1000 metric ton of CO2 equivalent) in 2000 in Peru to that in Philippines?
Your answer should be compact. 0.66. What is the ratio of the Emissions (1000 metric ton of CO2 equivalent) of 2005 in Peru to that in Philippines?
Keep it short and to the point. 0.65. What is the ratio of the Emissions (1000 metric ton of CO2 equivalent) in 2008 in Peru to that in Philippines?
Offer a terse response. 0.64. What is the difference between the highest and the second highest Emissions (1000 metric ton of CO2 equivalent) in 1990?
Offer a terse response. 6578. What is the difference between the highest and the second highest Emissions (1000 metric ton of CO2 equivalent) of 2000?
Provide a short and direct response. 8932.4. What is the difference between the highest and the second highest Emissions (1000 metric ton of CO2 equivalent) of 2005?
Ensure brevity in your answer.  1.05e+04. What is the difference between the highest and the second highest Emissions (1000 metric ton of CO2 equivalent) in 2008?
Provide a short and direct response. 1.17e+04. What is the difference between the highest and the lowest Emissions (1000 metric ton of CO2 equivalent) of 1990?
Keep it short and to the point. 1.34e+04. What is the difference between the highest and the lowest Emissions (1000 metric ton of CO2 equivalent) in 2000?
Make the answer very short. 1.75e+04. What is the difference between the highest and the lowest Emissions (1000 metric ton of CO2 equivalent) in 2005?
Keep it short and to the point. 1.95e+04. What is the difference between the highest and the lowest Emissions (1000 metric ton of CO2 equivalent) in 2008?
Offer a very short reply. 2.10e+04. 